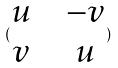Convert formula to latex. <formula><loc_0><loc_0><loc_500><loc_500>( \begin{matrix} u & & - v \\ v & & u \end{matrix} )</formula> 